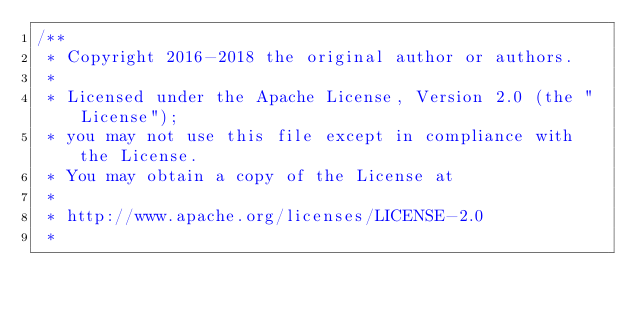<code> <loc_0><loc_0><loc_500><loc_500><_Java_>/**
 * Copyright 2016-2018 the original author or authors.
 *
 * Licensed under the Apache License, Version 2.0 (the "License");
 * you may not use this file except in compliance with the License.
 * You may obtain a copy of the License at
 *
 * http://www.apache.org/licenses/LICENSE-2.0
 *</code> 